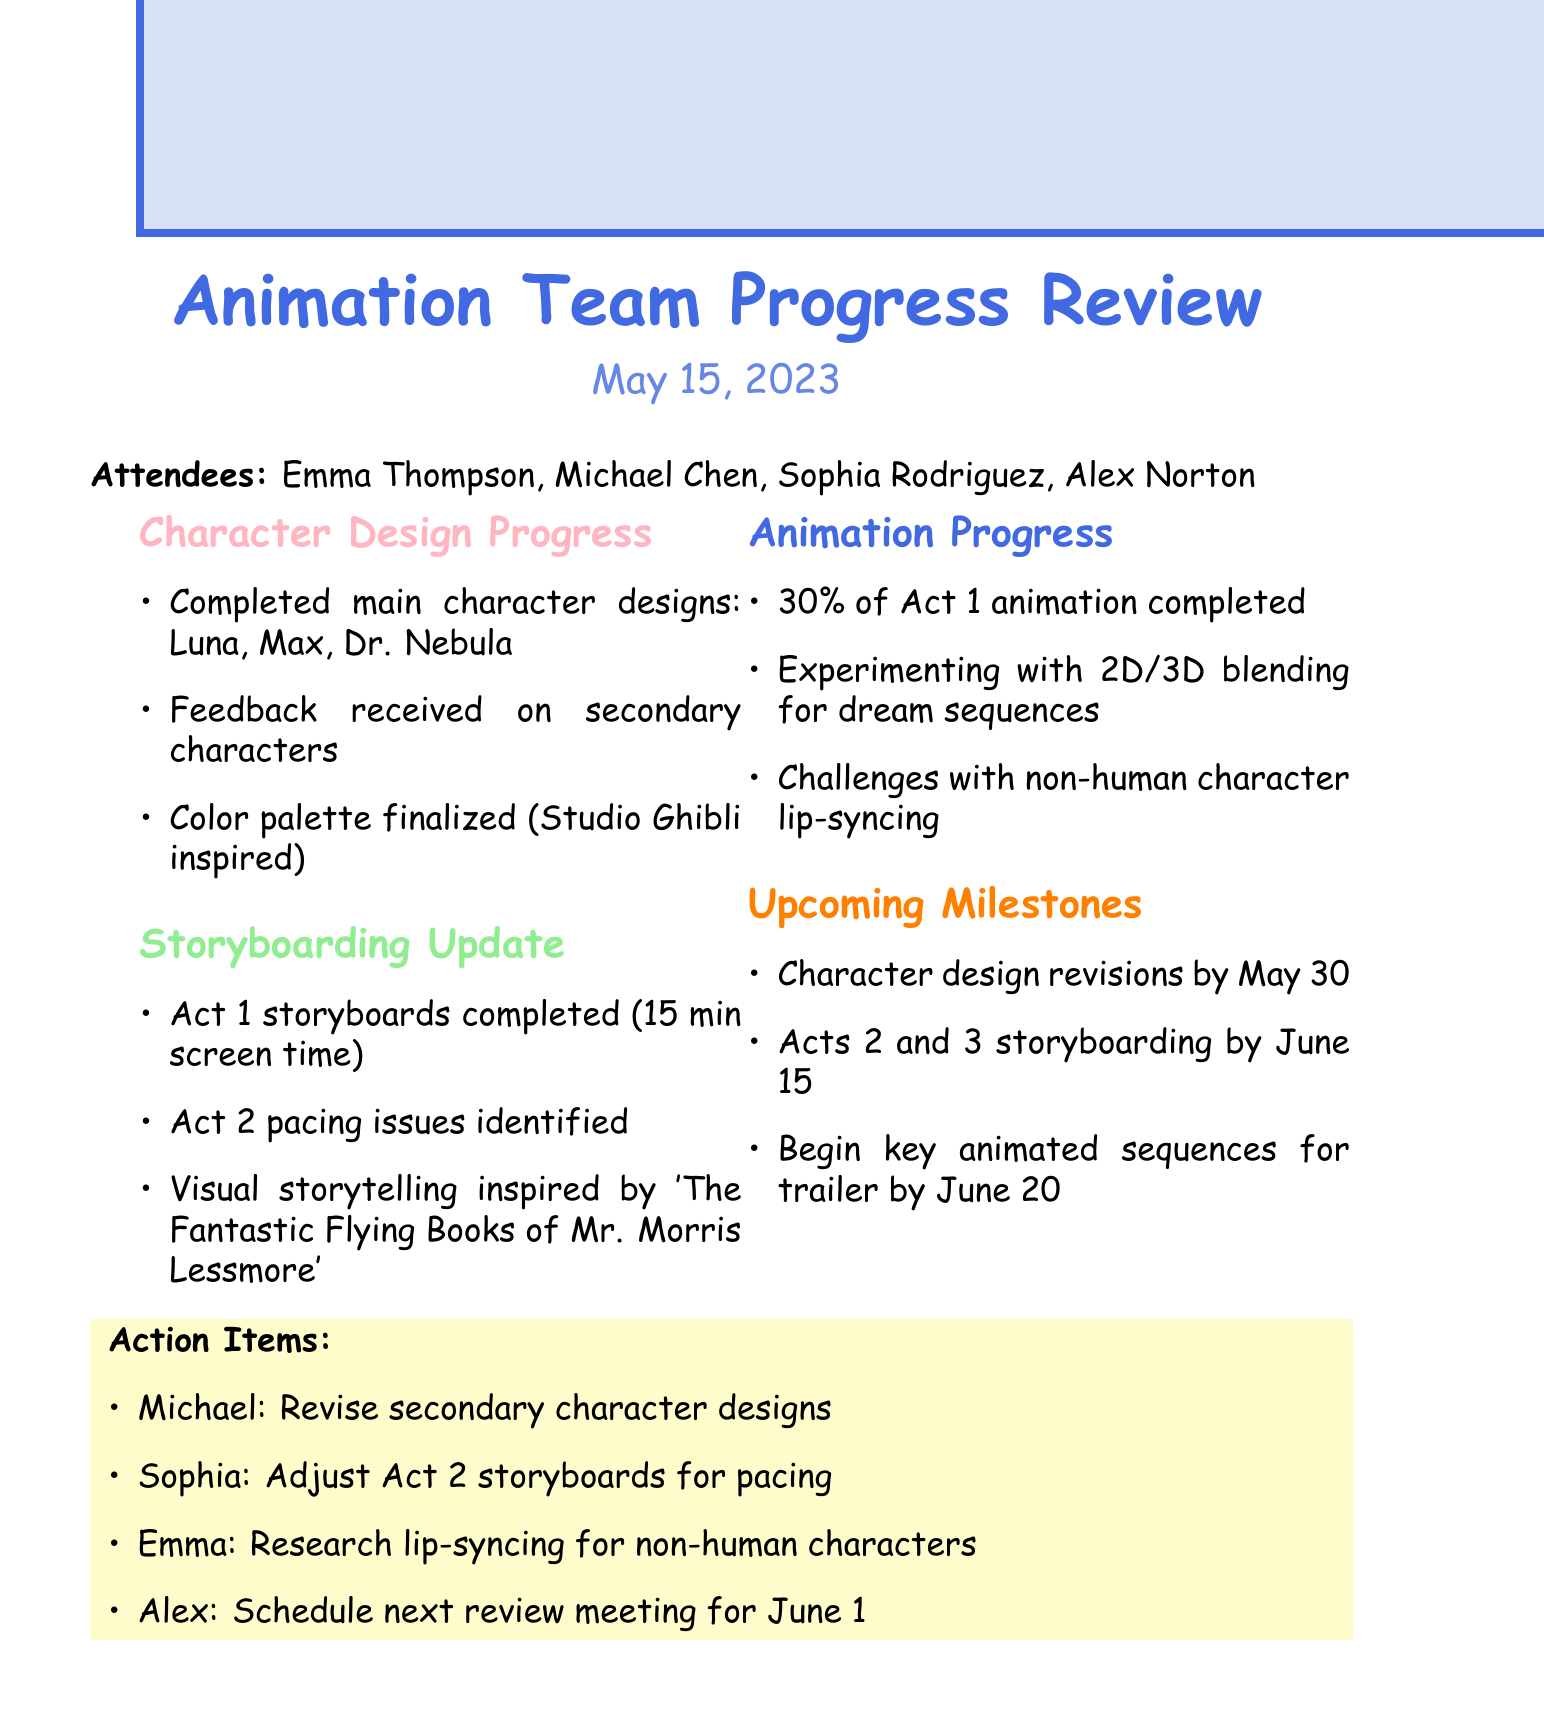What is the date of the meeting? The date of the meeting is listed at the top of the document under the meeting title.
Answer: May 15, 2023 Who is the Lead Animator? The Lead Animator is mentioned in the attendees list.
Answer: Emma Thompson What characters have completed designs? The completed designs for main characters are specified in the character design progress section.
Answer: Luna, Max, Dr. Nebula What percentage of Act 1 animation is completed? The percentage of completed animation for Act 1 is stated in the animation progress section.
Answer: 30% What is the deadline for secondary character design revisions? The deadline for character design revisions can be found in the upcoming milestones section.
Answer: May 30 What pacing issues were identified? The pacing issues are described in the storyboarding update section, referring to which act.
Answer: Act 2 How many minutes of screen time does Act 1 storyboards cover? The duration of screen time for Act 1 is noted in the storyboarding update.
Answer: 15 minutes Who is responsible for adjusting Act 2 storyboards? The specific action item identifies who will adjust the storyboards for pacing.
Answer: Sophia What is the next scheduled review meeting date? The date for the next review meeting is mentioned in the action items section.
Answer: June 1 